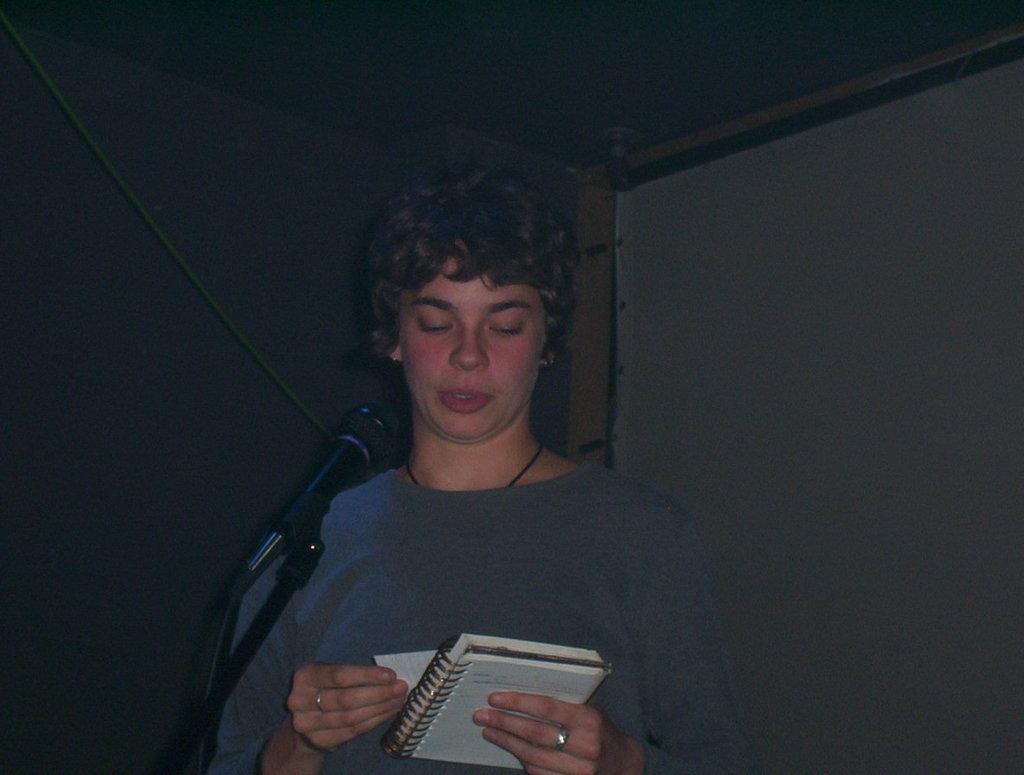In one or two sentences, can you explain what this image depicts? In the image there is a boy in grey t-shirt holding notebook talking on mic and behind him there is a banner on the wall. 